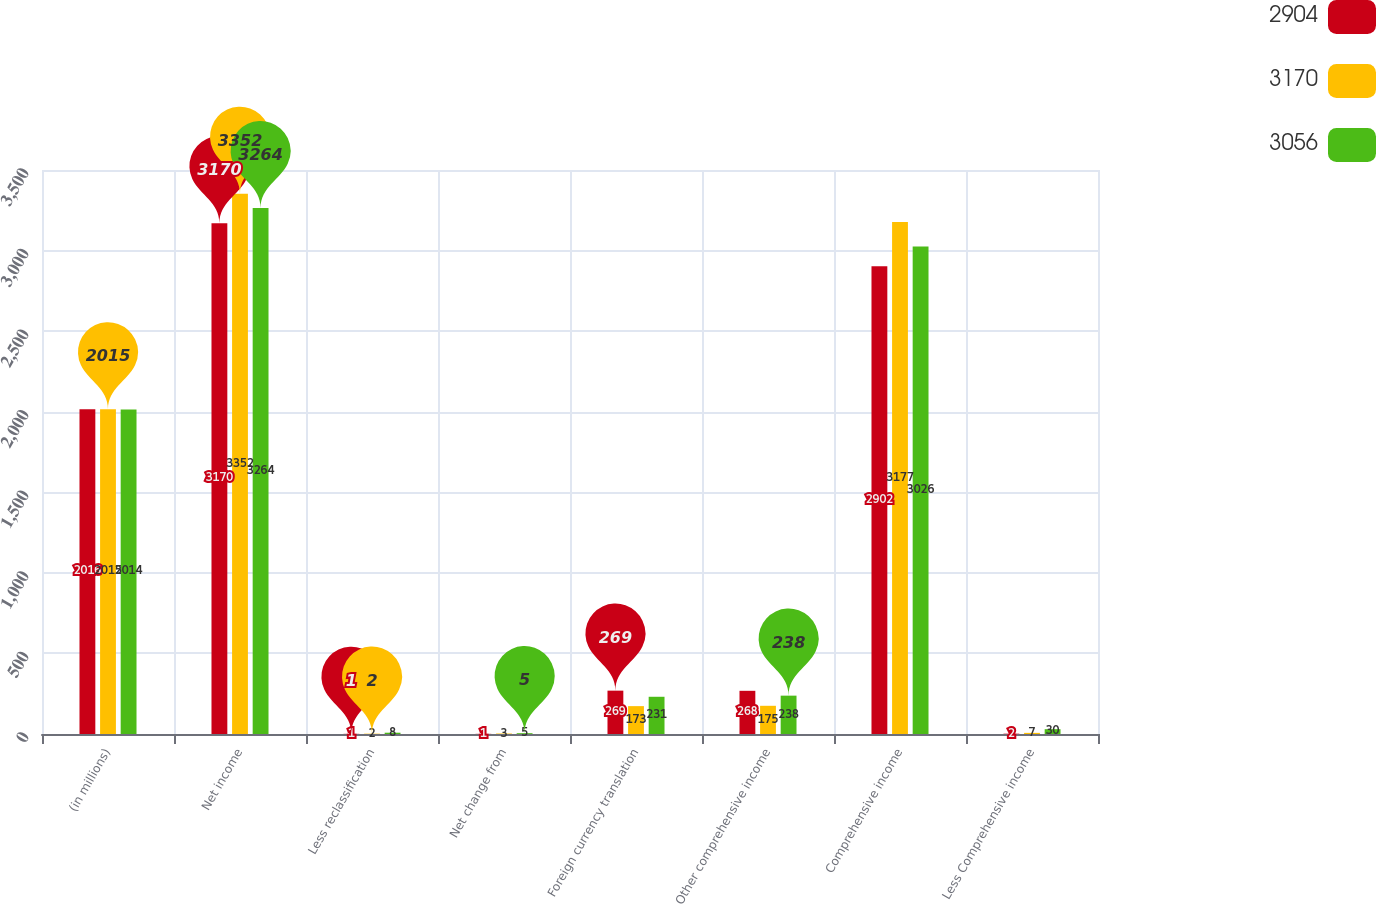<chart> <loc_0><loc_0><loc_500><loc_500><stacked_bar_chart><ecel><fcel>(in millions)<fcel>Net income<fcel>Less reclassification<fcel>Net change from<fcel>Foreign currency translation<fcel>Other comprehensive income<fcel>Comprehensive income<fcel>Less Comprehensive income<nl><fcel>2904<fcel>2016<fcel>3170<fcel>1<fcel>1<fcel>269<fcel>268<fcel>2902<fcel>2<nl><fcel>3170<fcel>2015<fcel>3352<fcel>2<fcel>3<fcel>173<fcel>175<fcel>3177<fcel>7<nl><fcel>3056<fcel>2014<fcel>3264<fcel>8<fcel>5<fcel>231<fcel>238<fcel>3026<fcel>30<nl></chart> 